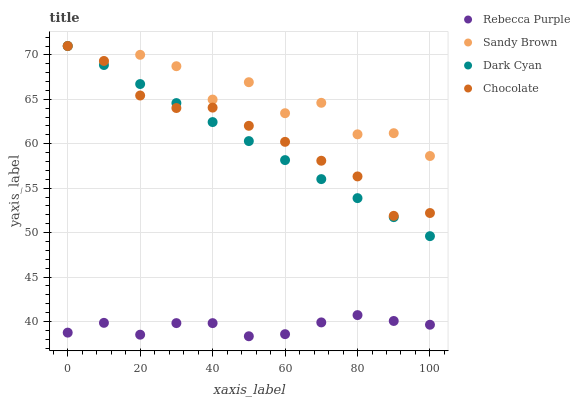Does Rebecca Purple have the minimum area under the curve?
Answer yes or no. Yes. Does Sandy Brown have the maximum area under the curve?
Answer yes or no. Yes. Does Sandy Brown have the minimum area under the curve?
Answer yes or no. No. Does Rebecca Purple have the maximum area under the curve?
Answer yes or no. No. Is Dark Cyan the smoothest?
Answer yes or no. Yes. Is Sandy Brown the roughest?
Answer yes or no. Yes. Is Rebecca Purple the smoothest?
Answer yes or no. No. Is Rebecca Purple the roughest?
Answer yes or no. No. Does Rebecca Purple have the lowest value?
Answer yes or no. Yes. Does Sandy Brown have the lowest value?
Answer yes or no. No. Does Chocolate have the highest value?
Answer yes or no. Yes. Does Rebecca Purple have the highest value?
Answer yes or no. No. Is Rebecca Purple less than Dark Cyan?
Answer yes or no. Yes. Is Chocolate greater than Rebecca Purple?
Answer yes or no. Yes. Does Sandy Brown intersect Chocolate?
Answer yes or no. Yes. Is Sandy Brown less than Chocolate?
Answer yes or no. No. Is Sandy Brown greater than Chocolate?
Answer yes or no. No. Does Rebecca Purple intersect Dark Cyan?
Answer yes or no. No. 